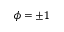Convert formula to latex. <formula><loc_0><loc_0><loc_500><loc_500>\phi = \pm 1</formula> 